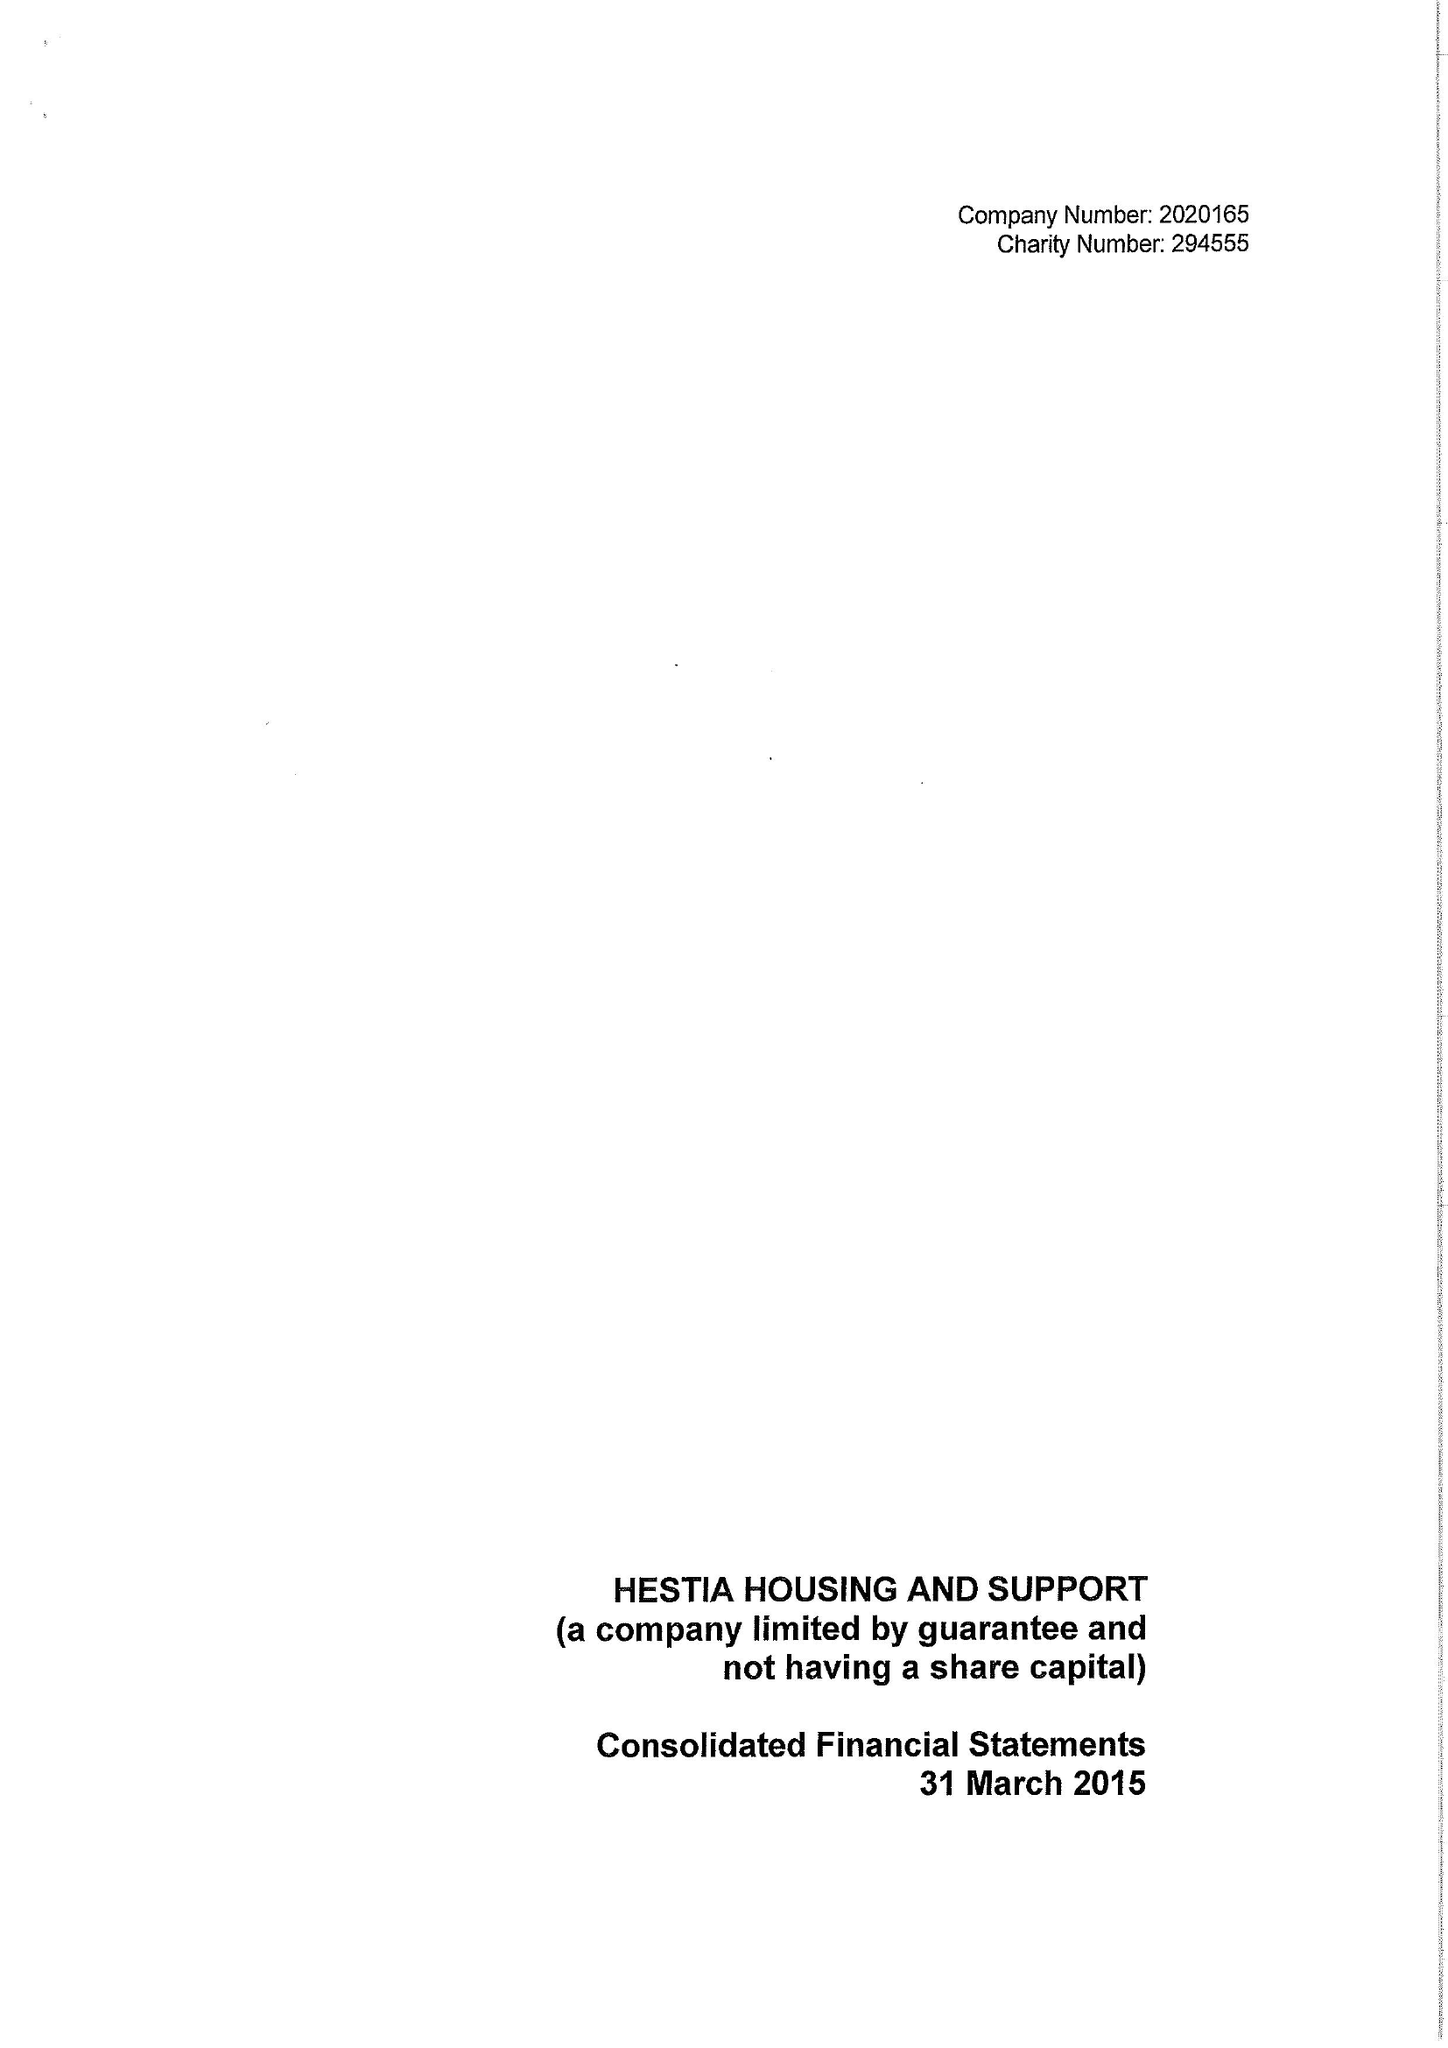What is the value for the spending_annually_in_british_pounds?
Answer the question using a single word or phrase. 21458774.00 